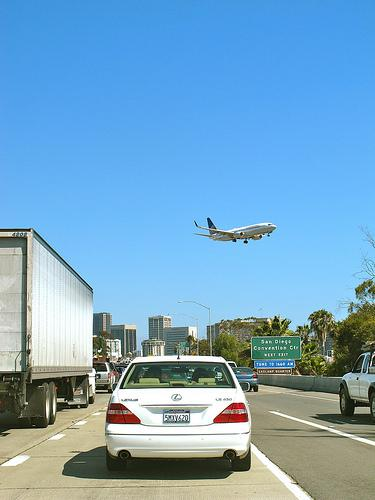Question: what is the color of the aeroplane?
Choices:
A. Blue.
B. Mainly white.
C. Black.
D. Orange.
Answer with the letter. Answer: B Question: what is the color of the sky?
Choices:
A. Red.
B. White.
C. Black.
D. Blue.
Answer with the letter. Answer: D Question: what is the color of the road?
Choices:
A. Grey.
B. Black.
C. Brown.
D. Red.
Answer with the letter. Answer: A 